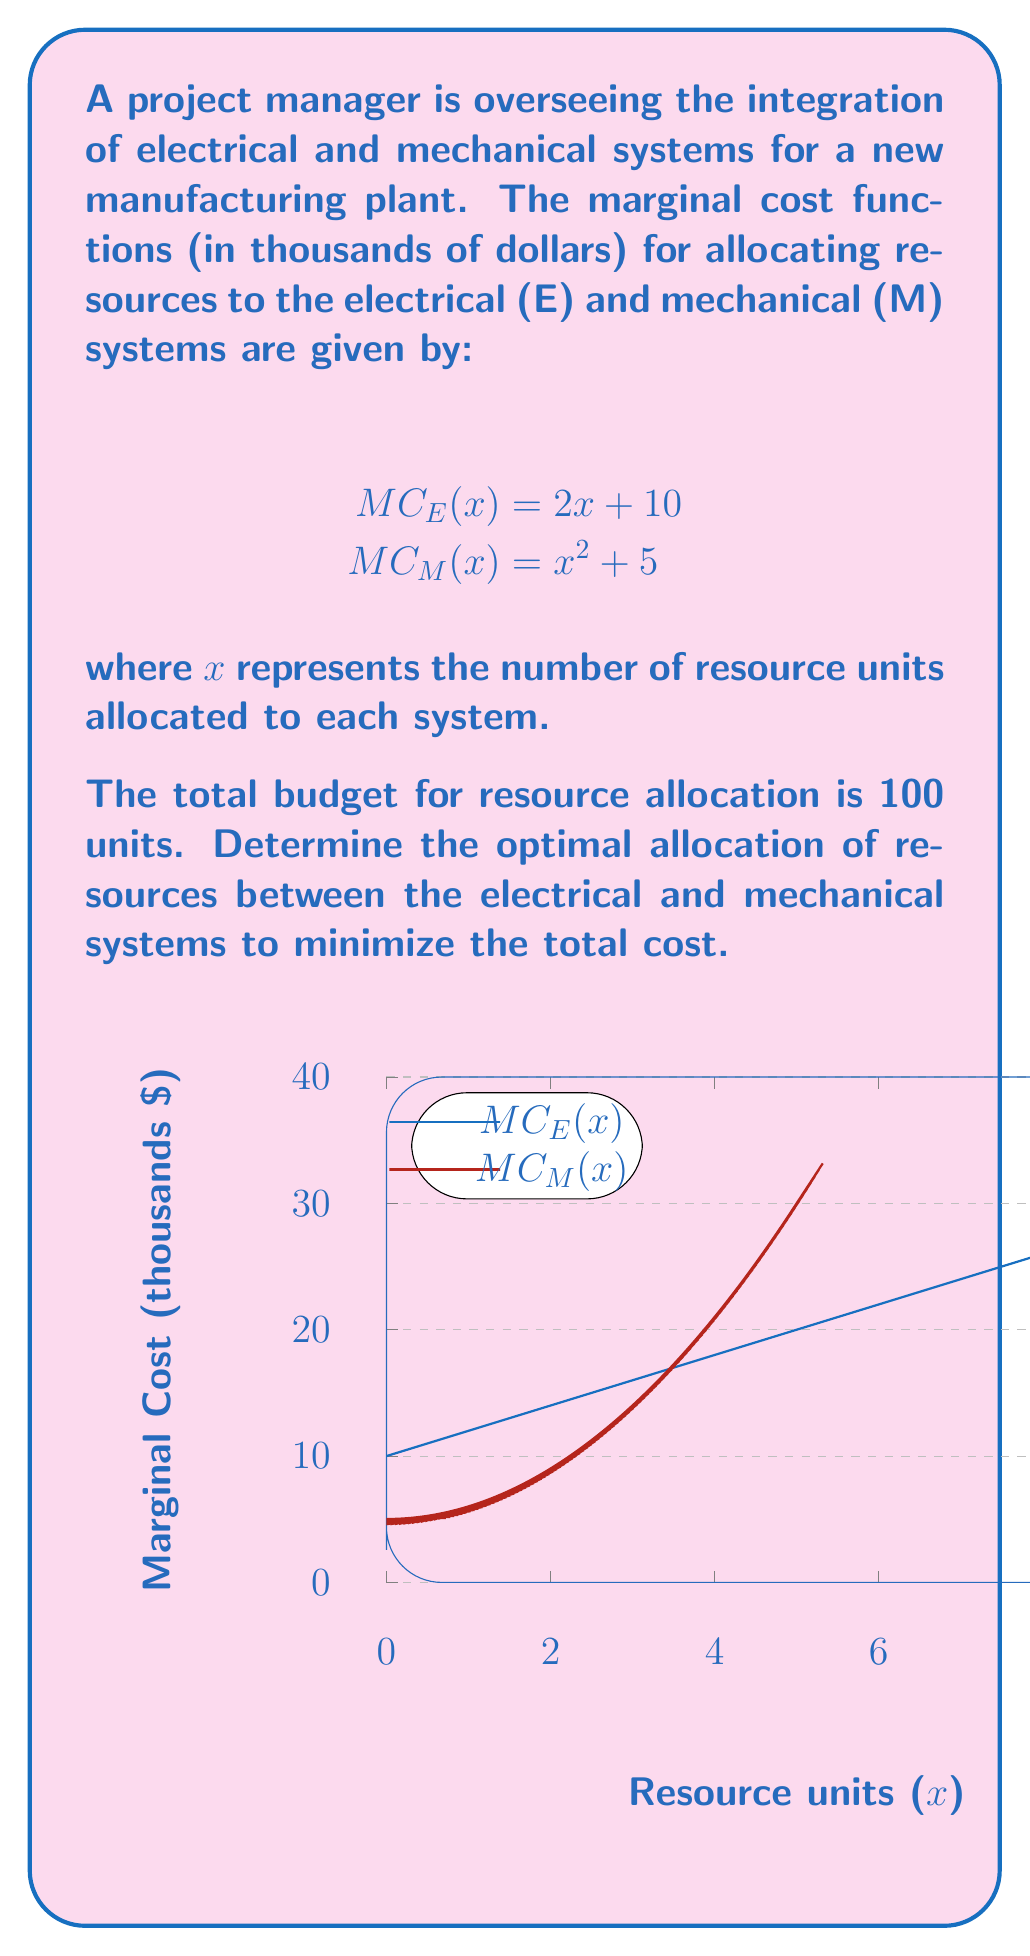Show me your answer to this math problem. To find the optimal allocation, we need to equate the marginal costs of both systems and solve for the total number of resource units. Let's approach this step-by-step:

1) The optimal allocation occurs when the marginal costs are equal:

   $$MC_E(x) = MC_M(y)$$

   where $x$ is the number of units allocated to the electrical system and $y$ is the number of units allocated to the mechanical system.

2) We also know that the total number of units is 100:

   $$x + y = 100$$

3) Substituting the given marginal cost functions:

   $$2x + 10 = y^2 + 5$$

4) Rearranging the equation from step 2:

   $$y = 100 - x$$

5) Substituting this into the equation from step 3:

   $$2x + 10 = (100 - x)^2 + 5$$

6) Expanding the right side:

   $$2x + 10 = 10000 - 200x + x^2 + 5$$

7) Simplifying:

   $$x^2 - 202x + 9995 = 0$$

8) This is a quadratic equation. We can solve it using the quadratic formula:

   $$x = \frac{-b \pm \sqrt{b^2 - 4ac}}{2a}$$

   where $a = 1$, $b = -202$, and $c = 9995$

9) Solving:

   $$x = \frac{202 \pm \sqrt{40804 - 39980}}{2} = \frac{202 \pm \sqrt{824}}{2} = \frac{202 \pm 28.7}{2}$$

10) This gives us two solutions: $x \approx 115.35$ or $x \approx 86.65$

11) Since we can't allocate more than 100 units, the valid solution is $x \approx 86.65$

12) Therefore, $y = 100 - 86.65 = 13.35$

So, the optimal allocation is approximately 86.65 units to the electrical system and 13.35 units to the mechanical system.
Answer: Electrical: 86.65 units, Mechanical: 13.35 units 